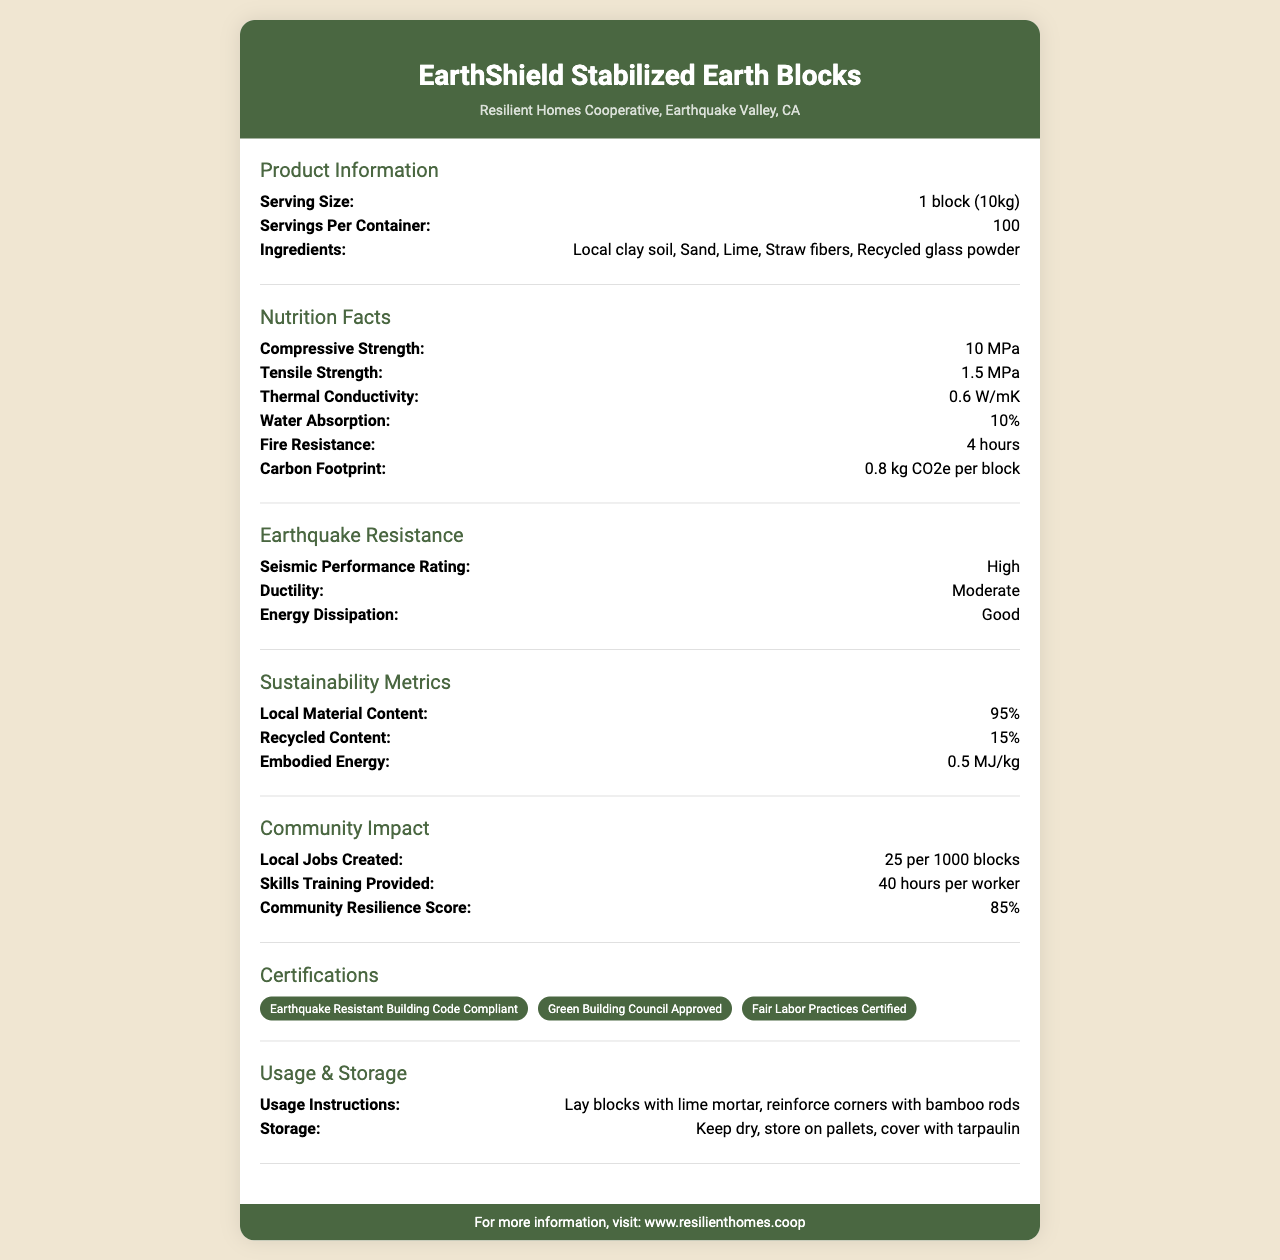what is the compressive strength of a block? The compressive strength of a block is explicitly stated under the "Nutrition Facts" section as 10 MPa.
Answer: 10 MPa what ingredients are used in EarthShield Stabilized Earth Blocks? The ingredients are listed in the "Ingredients" section as Local clay soil, Sand, Lime, Straw fibers, and Recycled glass powder.
Answer: Local clay soil, Sand, Lime, Straw fibers, Recycled glass powder how many blocks are there per container? The "Servings Per Container" section specifies that there are 100 blocks per container.
Answer: 100 what is the thermal conductivity of the blocks? The thermal conductivity is listed in the "Nutrition Facts" section as 0.6 W/mK.
Answer: 0.6 W/mK how long is the fire resistance for the blocks? The fire resistance duration is stated in the "Nutrition Facts" section as 4 hours.
Answer: 4 hours what percentage of local material content is used in these blocks? Under the "Sustainability Metrics" section, it is mentioned that the local material content is 95%.
Answer: 95% who is the manufacturer of these blocks? The manufacturer information is listed in the header section as Resilient Homes Cooperative, Earthquake Valley, CA.
Answer: Resilient Homes Cooperative, Earthquake Valley, CA which certification confirms the blocks are suited for earthquake resistance? One of the certifications listed is "Earthquake Resistant Building Code Compliant."
Answer: Earthquake Resistant Building Code Compliant how much carbon is emitted per block? The carbon footprint is given in the "Nutrition Facts" section as 0.8 kg CO2e per block.
Answer: 0.8 kg CO2e per block how many jobs are created for every 1000 blocks produced? The "Community Impact" section states that 25 jobs are created per 1000 blocks.
Answer: 25 per 1000 blocks what is the recommended storage condition for the blocks? The usage and storage instructions recommend keeping the blocks dry, stored on pallets, and covered with tarpaulin.
Answer: Keep dry, store on pallets, cover with tarpaulin what is the website for more information on this product? The footer of the document points to www.resilienthomes.coop for more information.
Answer: www.resilienthomes.coop what is the seismic performance rating? A. Low B. Moderate C. High D. Very High The "Earthquake Resistance" section lists the seismic performance rating as High.
Answer: C what is the tensile strength of the EarthShield Stabilized Earth Blocks? A. 1.5 MPa B. 10 MPa C. 0.6 W/mK D. 10% The tensile strength is shown in the "Nutrition Facts" section as 1.5 MPa.
Answer: A is the product compliant with earthquake-resistant building codes? One of the certifications listed is "Earthquake Resistant Building Code Compliant," confirming compliance.
Answer: Yes provide a summary of the document. The document outlines key properties, sustainability, and community impact of EarthShield Stabilized Earth Blocks, a product designed for resilience and local resource use. It details the composition, strength metrics, certifications, and social benefits, emphasizing its suitability for earthquake-prone areas.
Answer: The EarthShield Stabilized Earth Blocks product from Resilient Homes Cooperative is an earthquake-resistant building material made from local resources like clay soil, sand, lime, straw fibers, and recycled glass. Each block weighs 10kg, with 100 blocks per container. The product boasts high seismic performance with metrics like 10 MPa compressive strength, 1.5 MPa tensile strength, and 4-hour fire resistance. Sustainability and community impact are highlighted with 95% local materials, job creation, and skills training for local workers. The blocks meet various certifications for green building and fair labor practices, and detailed usage and storage instructions are provided alongside a link for more information. what's the exact percentage of recycled content used in the blocks? The "Sustainability Metrics" section mentions that the recycled content is 15%.
Answer: 15% how do you lay the blocks? The usage instructions specify laying the blocks with lime mortar and reinforcing corners with bamboo rods.
Answer: Lay blocks with lime mortar, reinforce corners with bamboo rods what is the embodied energy per kg of the block? Under "Sustainability Metrics," the embodied energy is listed as 0.5 MJ/kg.
Answer: 0.5 MJ/kg how much energy dissipation do the blocks provide? The "Earthquake Resistance" section rates the energy dissipation of the blocks as Good.
Answer: Good does the document specify the color of the blocks? The document does not mention anything about the color of the blocks.
Answer: Not enough information 